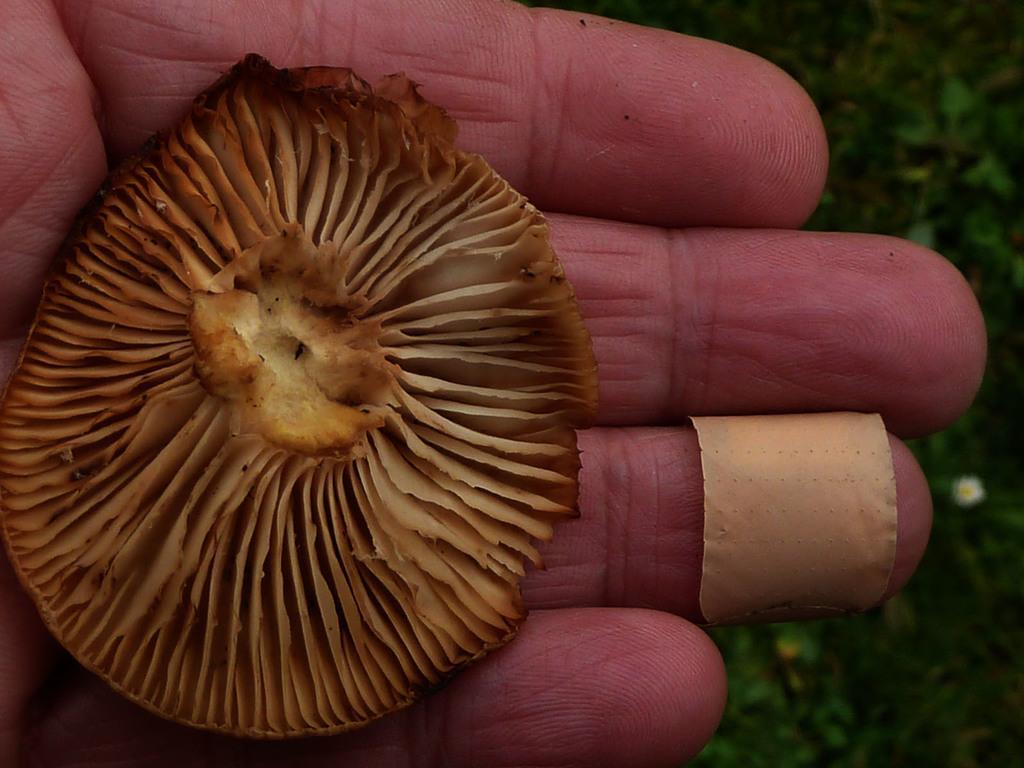Could you give a brief overview of what you see in this image? In this image, we can see a mushroom on the person's hand and there is a bandage to the finger. In the background, there are trees. 